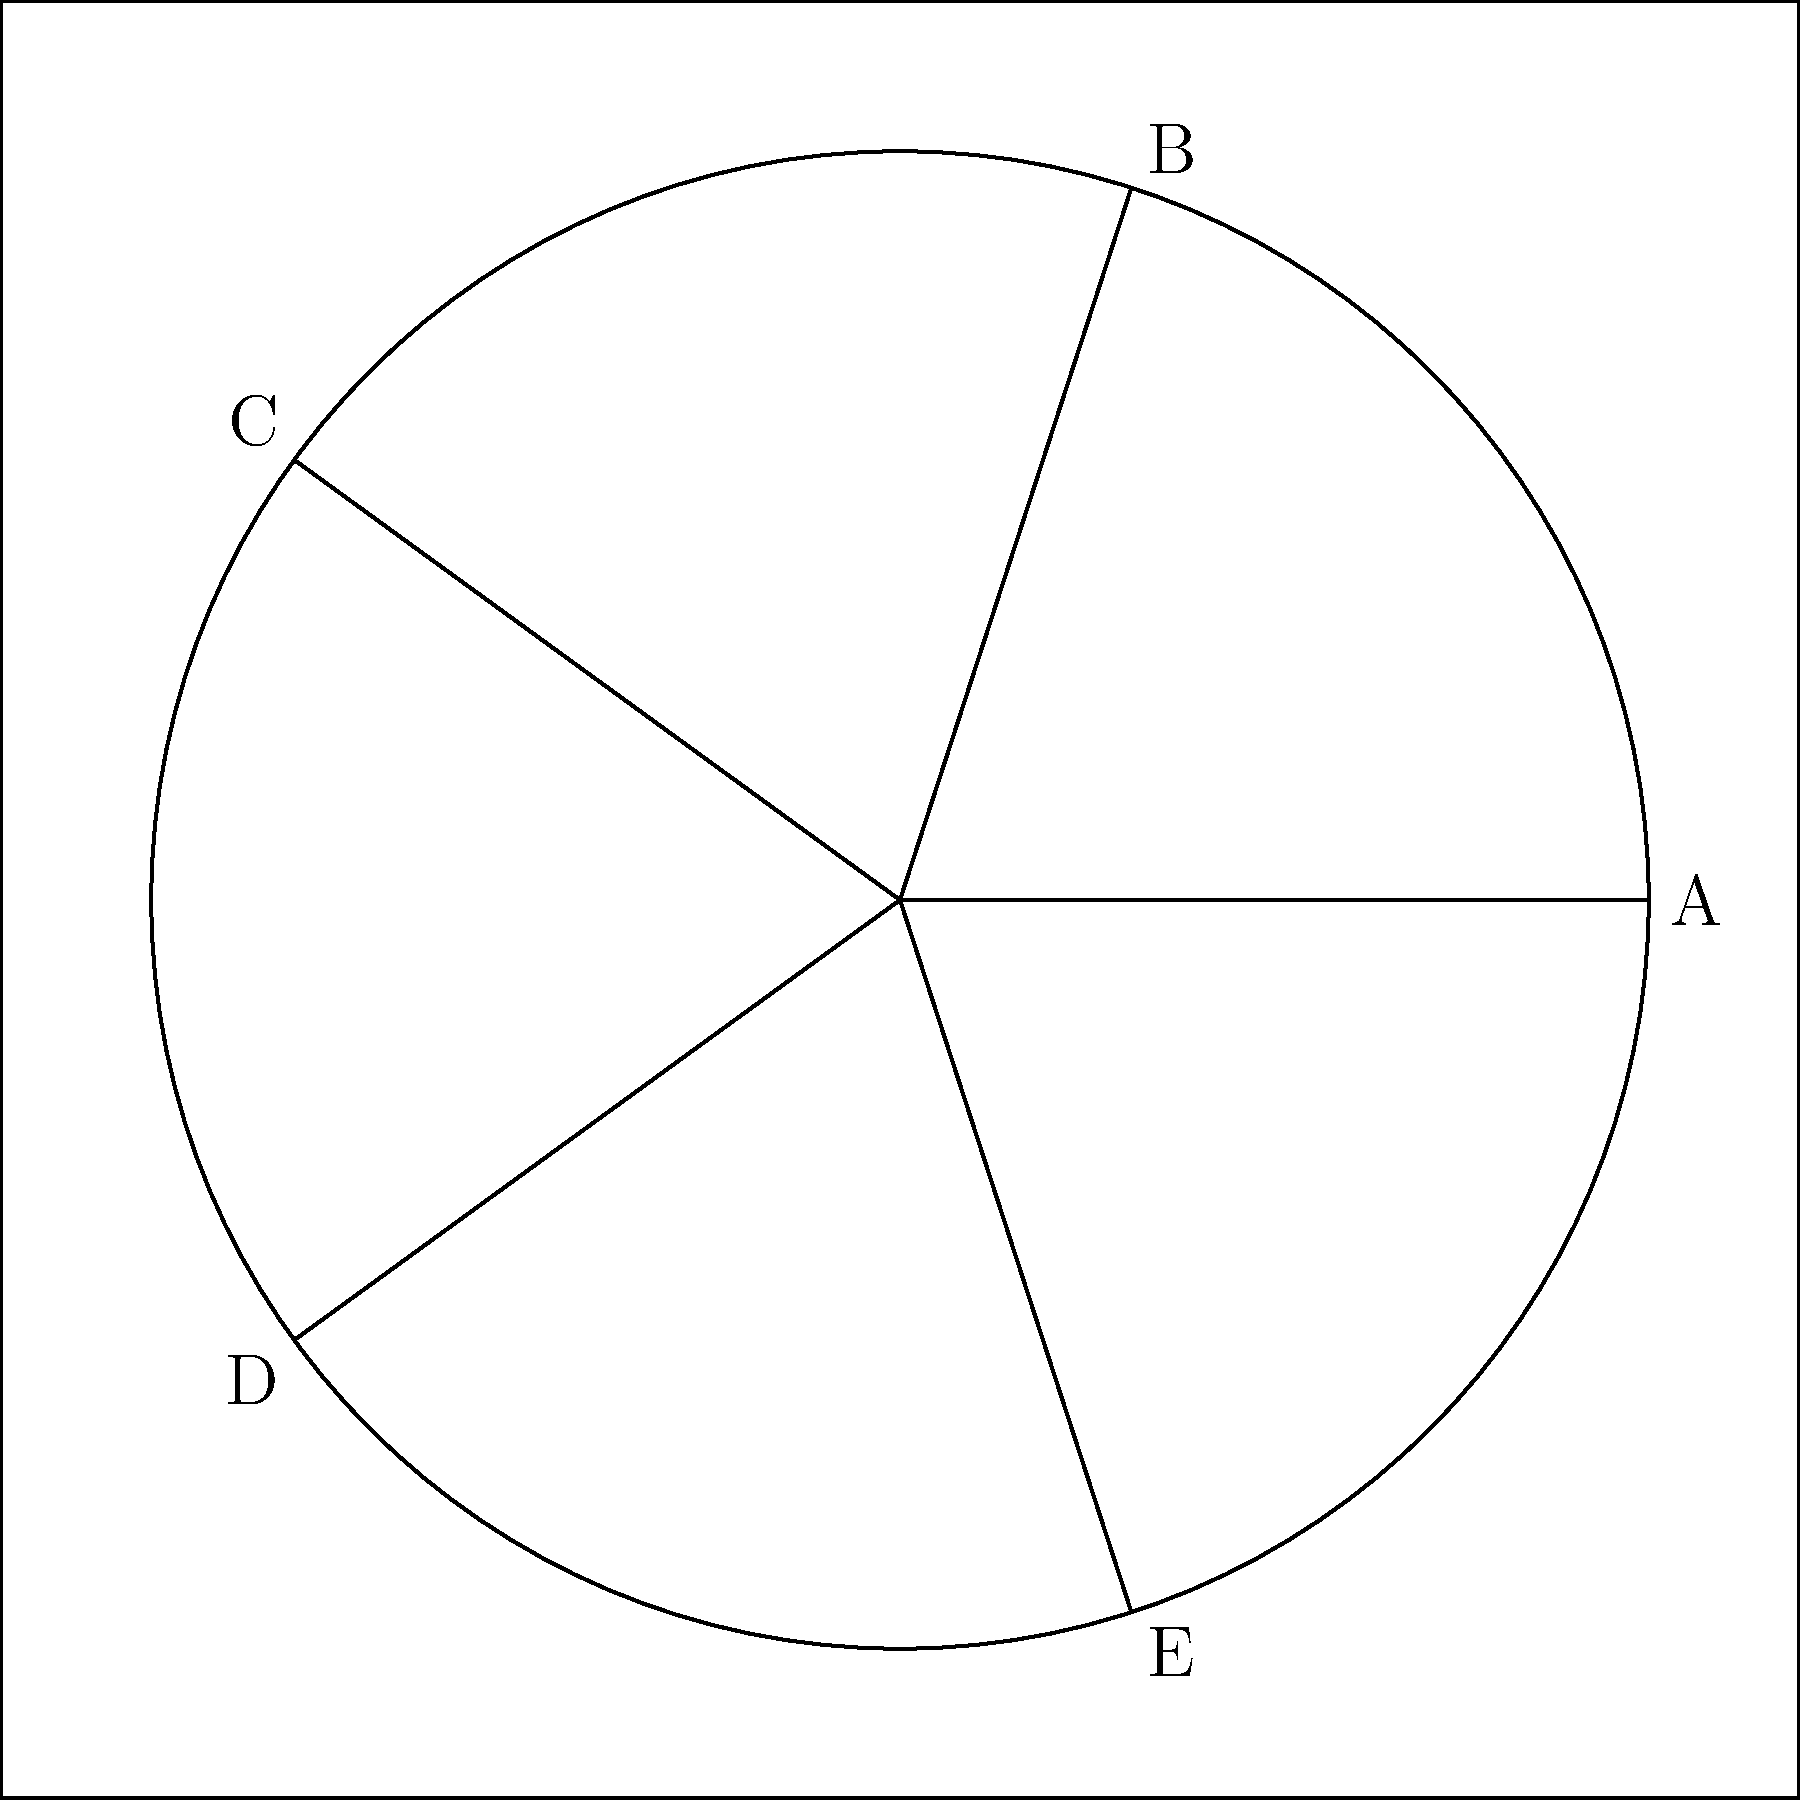The image above represents a simplified version of a diplomatic seal. Which country is known for using a five-pointed star in its national emblem, similar to the one shown? To identify the country associated with this seal, let's analyze the key features:

1. The seal contains a five-pointed star (pentagram) inscribed in a circle.
2. Five-pointed stars are common in many national emblems, but their presentation and context vary.
3. In this case, the star is presented in a simple, symmetrical form without additional elements.
4. Among countries known for prominently featuring a five-pointed star in their national emblems:

   a) China uses a large five-pointed star accompanied by four smaller stars.
   b) Vietnam uses a single yellow five-pointed star on a red background.
   c) Morocco uses a green five-pointed star (pentagram) on a red background.

5. The simplicity and standalone nature of this star most closely resemble Morocco's use of the five-pointed star in its flag and national emblem.

Therefore, based on the given information and the simplicity of the design, the country most likely to use this type of seal in its diplomatic correspondence is Morocco.
Answer: Morocco 